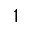<formula> <loc_0><loc_0><loc_500><loc_500>1</formula> 